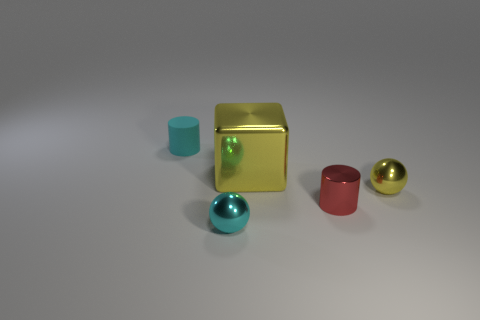Add 3 small yellow metal spheres. How many objects exist? 8 Subtract all balls. How many objects are left? 3 Add 5 red cylinders. How many red cylinders are left? 6 Add 4 tiny shiny spheres. How many tiny shiny spheres exist? 6 Subtract 0 brown balls. How many objects are left? 5 Subtract all large blue cylinders. Subtract all tiny yellow balls. How many objects are left? 4 